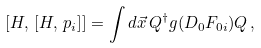<formula> <loc_0><loc_0><loc_500><loc_500>[ H , \, [ H , \, p _ { i } ] ] = \int d \vec { x } \, Q ^ { \dagger } g ( D _ { 0 } F _ { 0 i } ) Q \, ,</formula> 